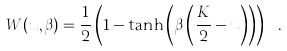Convert formula to latex. <formula><loc_0><loc_0><loc_500><loc_500>W ( u , \beta ) = \frac { 1 } { 2 } \left ( 1 - \tanh \left ( \beta \left ( \frac { K } { 2 } - u \right ) \right ) \right ) \ .</formula> 